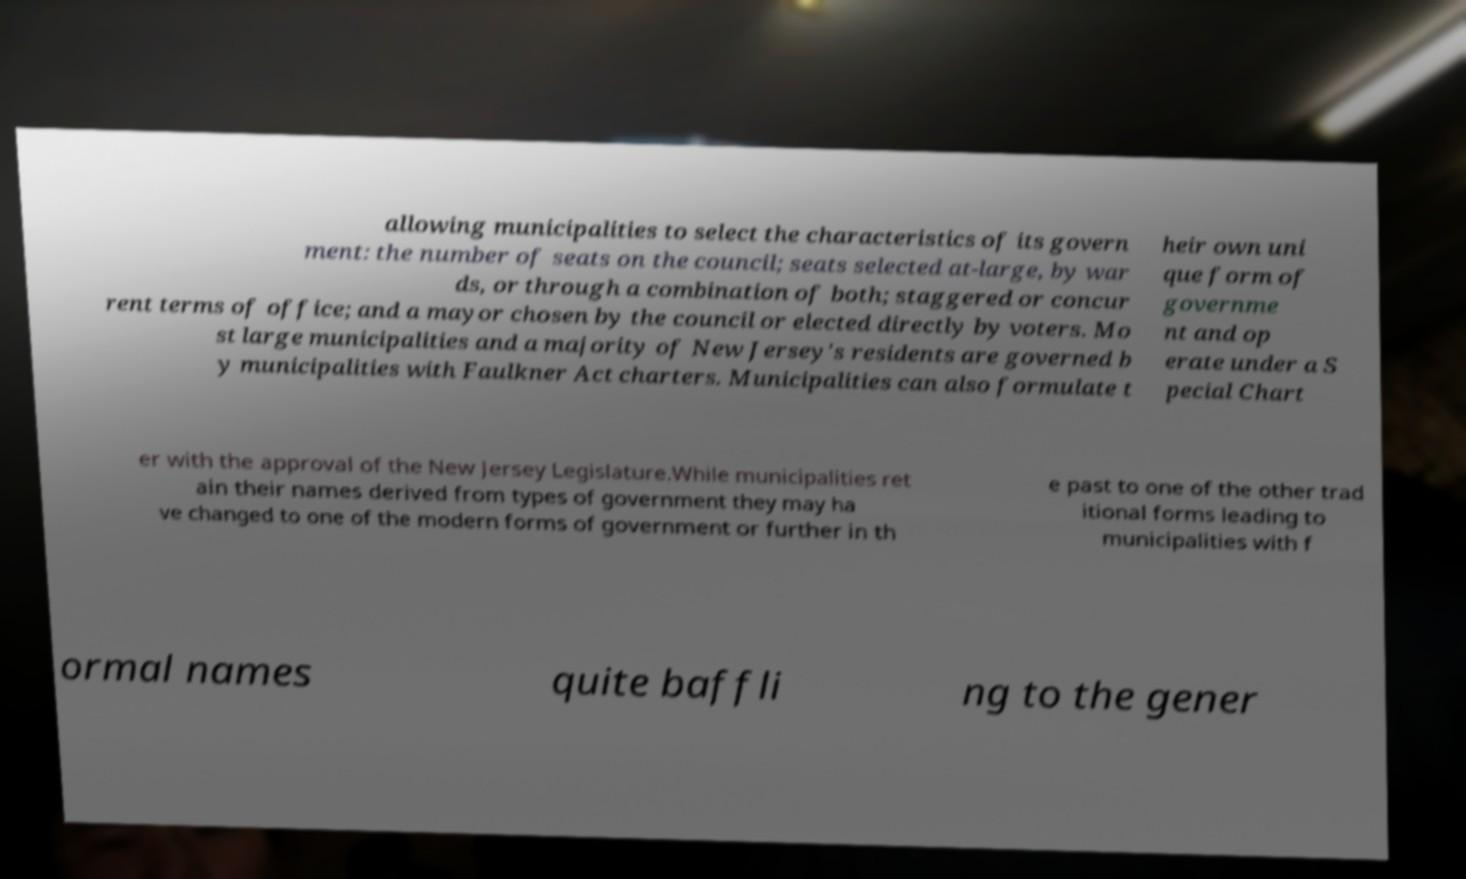There's text embedded in this image that I need extracted. Can you transcribe it verbatim? allowing municipalities to select the characteristics of its govern ment: the number of seats on the council; seats selected at-large, by war ds, or through a combination of both; staggered or concur rent terms of office; and a mayor chosen by the council or elected directly by voters. Mo st large municipalities and a majority of New Jersey's residents are governed b y municipalities with Faulkner Act charters. Municipalities can also formulate t heir own uni que form of governme nt and op erate under a S pecial Chart er with the approval of the New Jersey Legislature.While municipalities ret ain their names derived from types of government they may ha ve changed to one of the modern forms of government or further in th e past to one of the other trad itional forms leading to municipalities with f ormal names quite baffli ng to the gener 